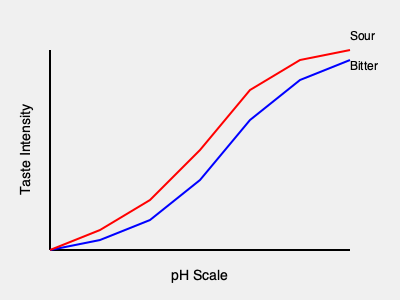As a mixologist with a chemistry background, how would you explain the relationship between pH and taste intensity in mixed drinks, based on the graph provided? What implications does this have for balancing flavors in cocktails? To answer this question, let's break down the information provided in the graph and relate it to mixology:

1. The graph shows two lines representing the taste intensity of sour (blue) and bitter (red) flavors across the pH scale.

2. pH scale interpretation:
   - Left side of the scale (lower pH): More acidic
   - Right side of the scale (higher pH): More alkaline

3. Sour taste (blue line):
   - Intensity increases as pH decreases (becomes more acidic)
   - This aligns with chemistry knowledge: sourness is directly related to acidity

4. Bitter taste (red line):
   - Also increases in intensity as pH decreases, but less dramatically than sourness
   - Bitterness is perceived across a wider pH range

5. Implications for mixology:
   a) Balancing acidity: Adding acidic ingredients (e.g., citrus juices) will lower the pH and increase sourness more rapidly than bitterness
   b) Layering flavors: The different slopes of the lines suggest that small pH changes can significantly alter the balance between sour and bitter tastes
   c) Sweetness (not shown in the graph) is often used to counterbalance both sour and bitter flavors in cocktails

6. Application in cocktail creation:
   - Use precise measurements of acidic and bitter components to achieve desired taste profiles
   - Understand that small adjustments in pH can have significant effects on overall flavor balance
   - Utilize ingredients with buffering capacity (e.g., certain syrups or liqueurs) to stabilize pH and maintain consistent taste

In conclusion, the graph demonstrates that pH plays a crucial role in determining the intensity of sour and bitter tastes in mixed drinks, with acidity having a more pronounced effect on sourness. This knowledge allows for precise flavor manipulation in cocktail creation.
Answer: pH significantly affects sour and bitter taste intensities; lower pH increases both, with a stronger effect on sourness. This allows for precise flavor balancing in cocktails through careful ingredient selection and measurement. 